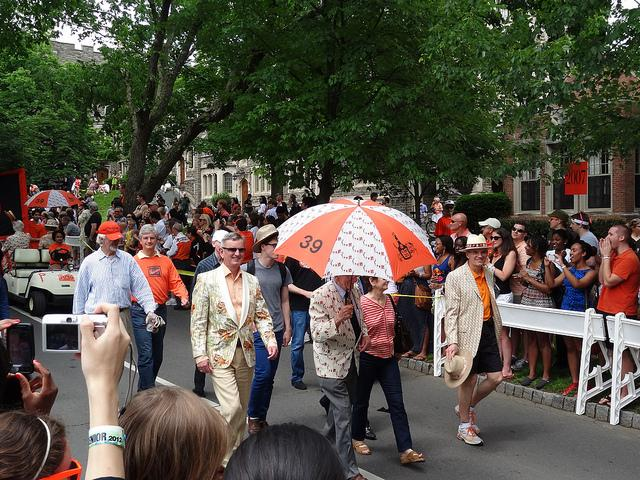What event is being filmed here? parade 